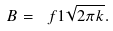<formula> <loc_0><loc_0><loc_500><loc_500>B = \ f { 1 } { \sqrt { 2 \pi k } } .</formula> 